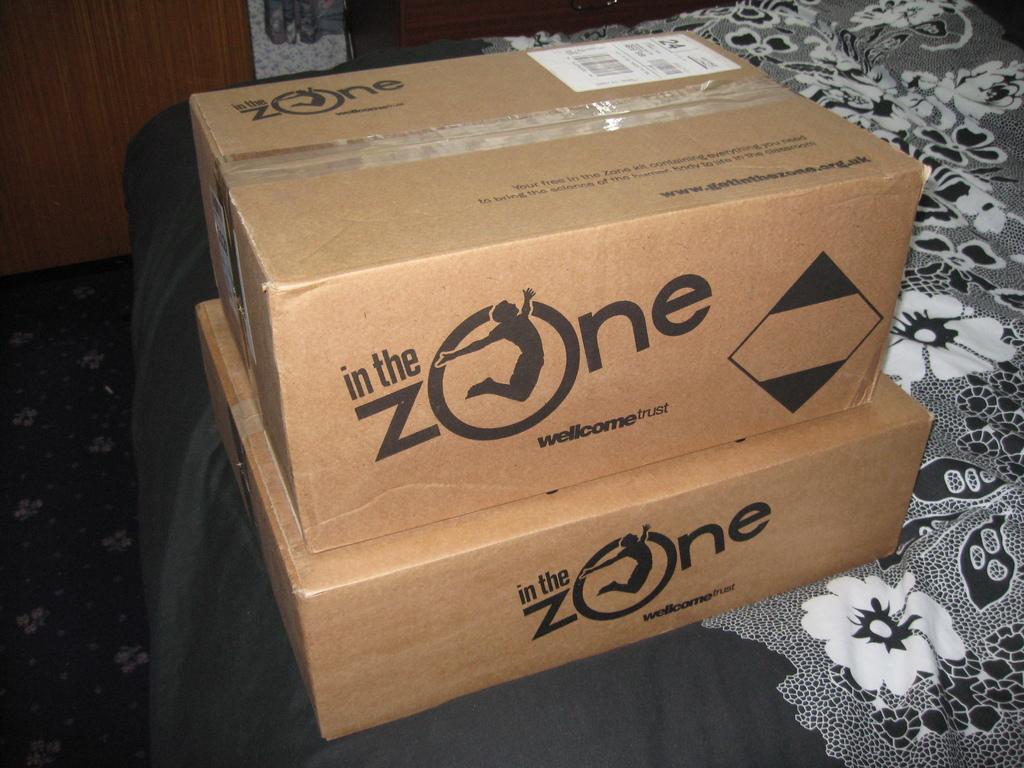What is the word that comes after the?
Your answer should be very brief. Zone. 